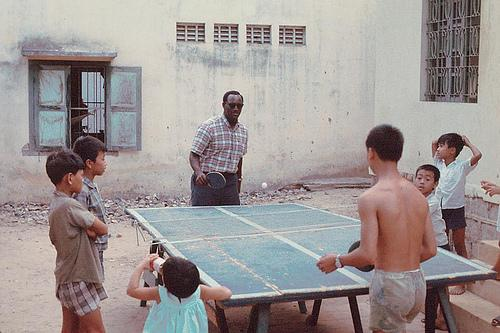Question: when are they playing?
Choices:
A. Daytime.
B. After school.
C. Twilight.
D. In the morning.
Answer with the letter. Answer: A Question: where are they playing the game?
Choices:
A. Park.
B. Yard.
C. School.
D. Soccer field.
Answer with the letter. Answer: B Question: how many people are in the picture?
Choices:
A. Seven.
B. Four.
C. Five.
D. Three.
Answer with the letter. Answer: A Question: how many windows are in the picture?
Choices:
A. Four.
B. Two.
C. Six.
D. One.
Answer with the letter. Answer: C Question: who is drinking from the bottle?
Choices:
A. The baseball player.
B. The asian woman.
C. The toddler.
D. Baby.
Answer with the letter. Answer: D Question: what game is being played?
Choices:
A. Ping Pong.
B. Pool.
C. Tether ball.
D. Hopscotch.
Answer with the letter. Answer: A 